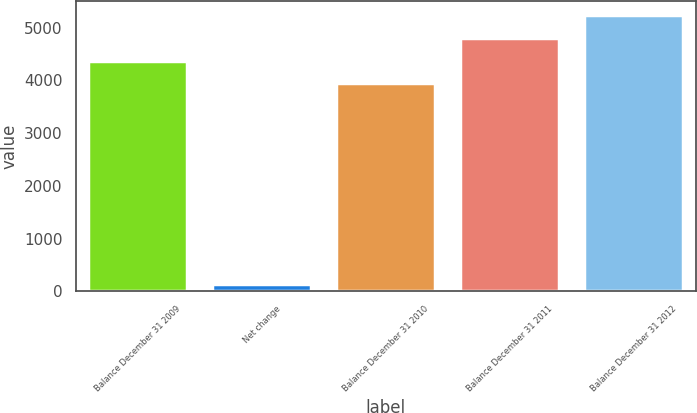Convert chart to OTSL. <chart><loc_0><loc_0><loc_500><loc_500><bar_chart><fcel>Balance December 31 2009<fcel>Net change<fcel>Balance December 31 2010<fcel>Balance December 31 2011<fcel>Balance December 31 2012<nl><fcel>4378.1<fcel>145<fcel>3947<fcel>4809.2<fcel>5240.3<nl></chart> 